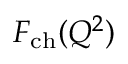Convert formula to latex. <formula><loc_0><loc_0><loc_500><loc_500>F _ { c h } ( Q ^ { 2 } )</formula> 